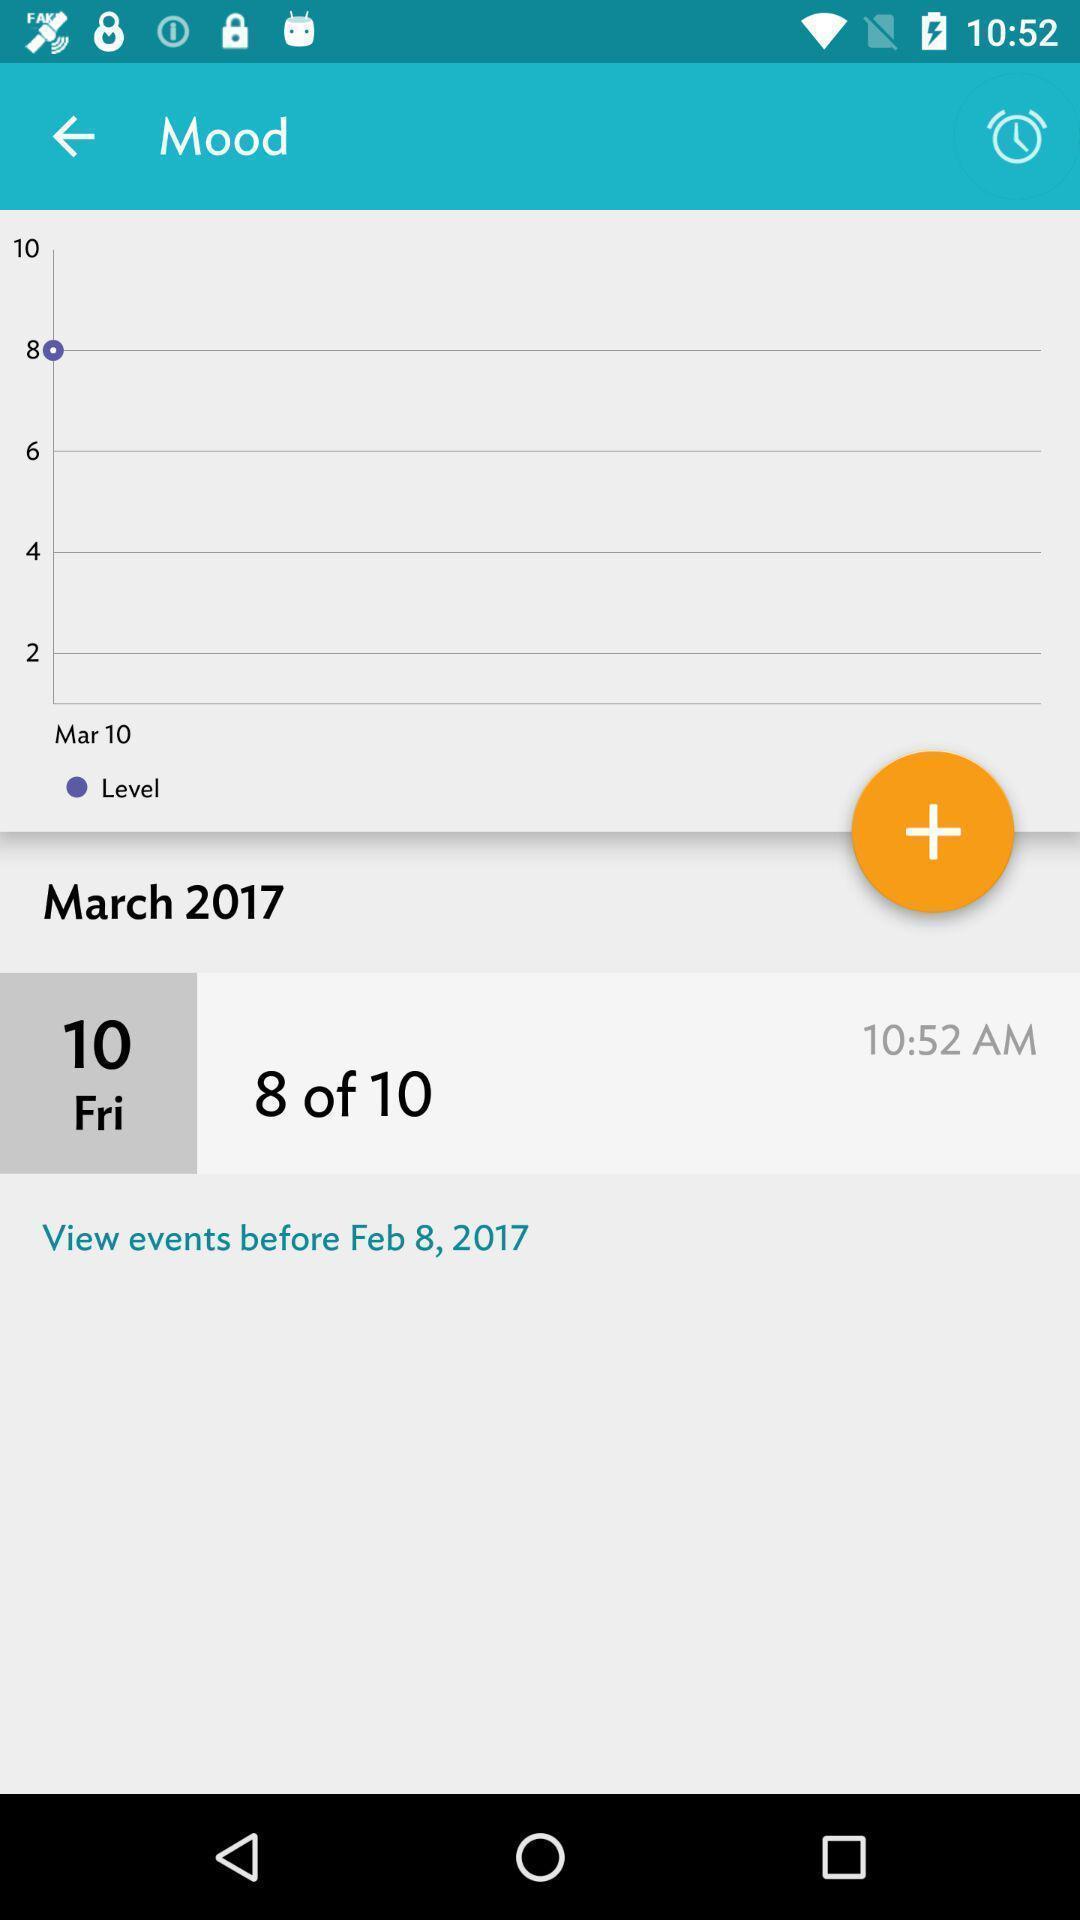Describe the key features of this screenshot. Screen displaying remainder set for a date. 